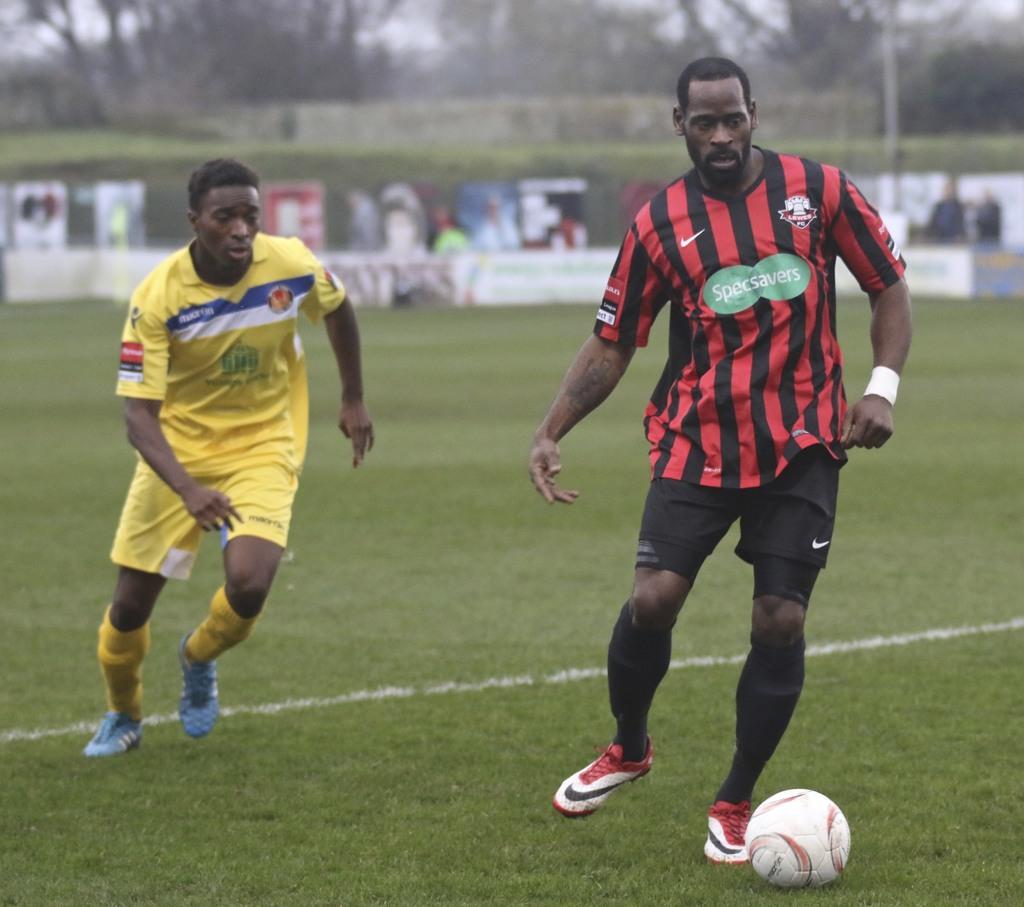What is the sponsor of the red and black striped jersey?
Your answer should be very brief. Specsavers. What does the black and red jersey's emblem say?
Your answer should be very brief. Specsavers. 